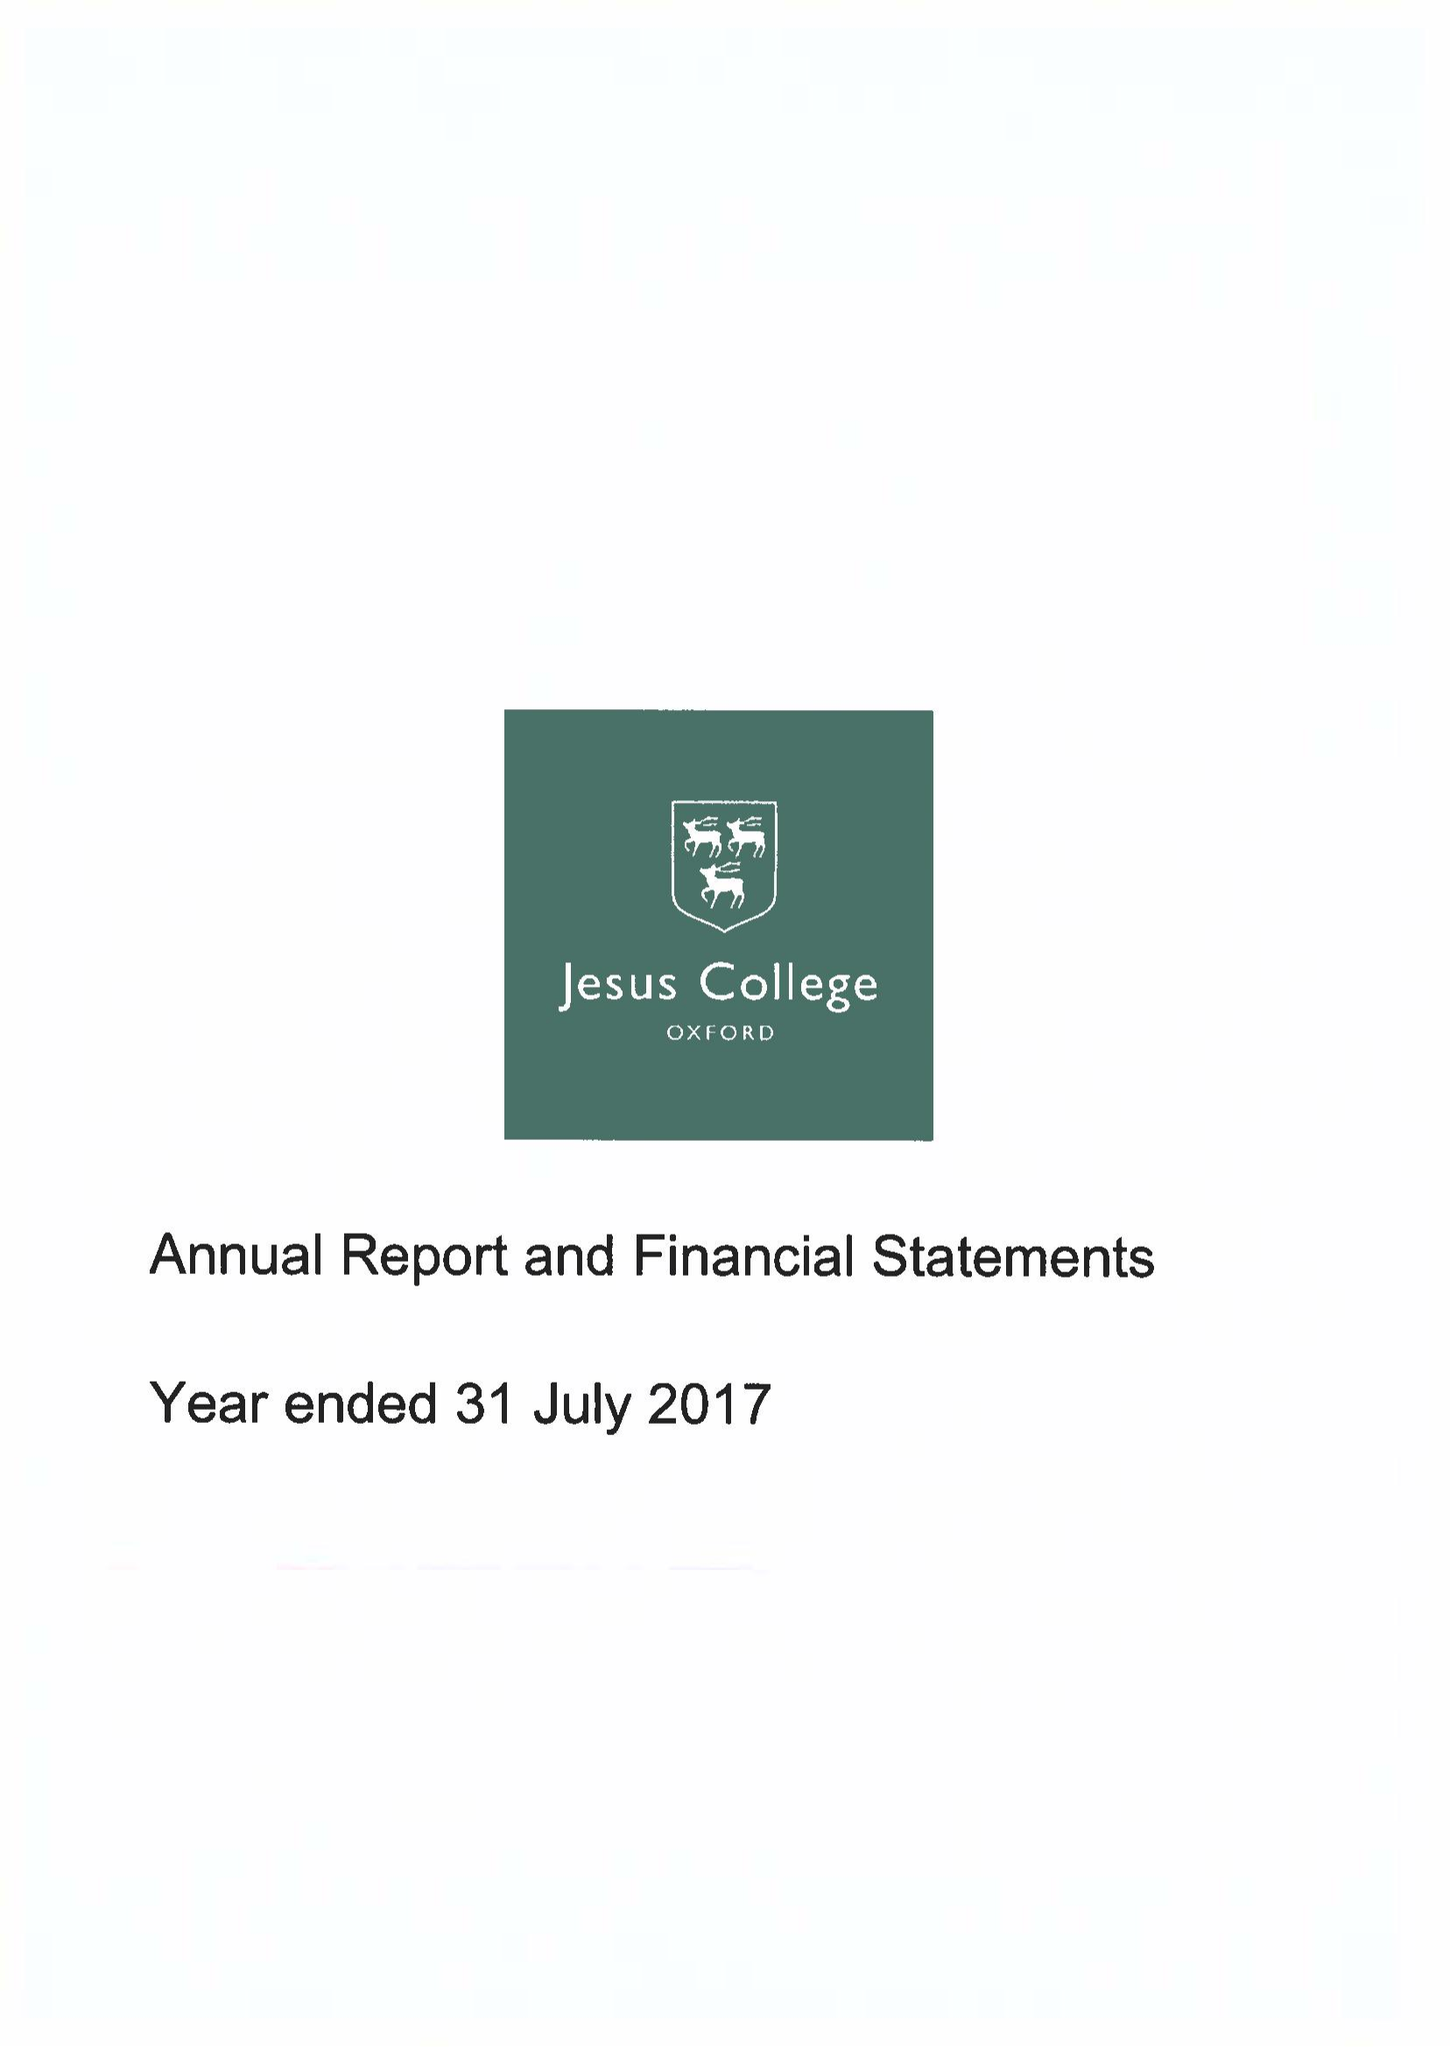What is the value for the charity_name?
Answer the question using a single word or phrase. Jesus College Within The University and City Of Oxford Of Queen Elizabeth's Foundation 